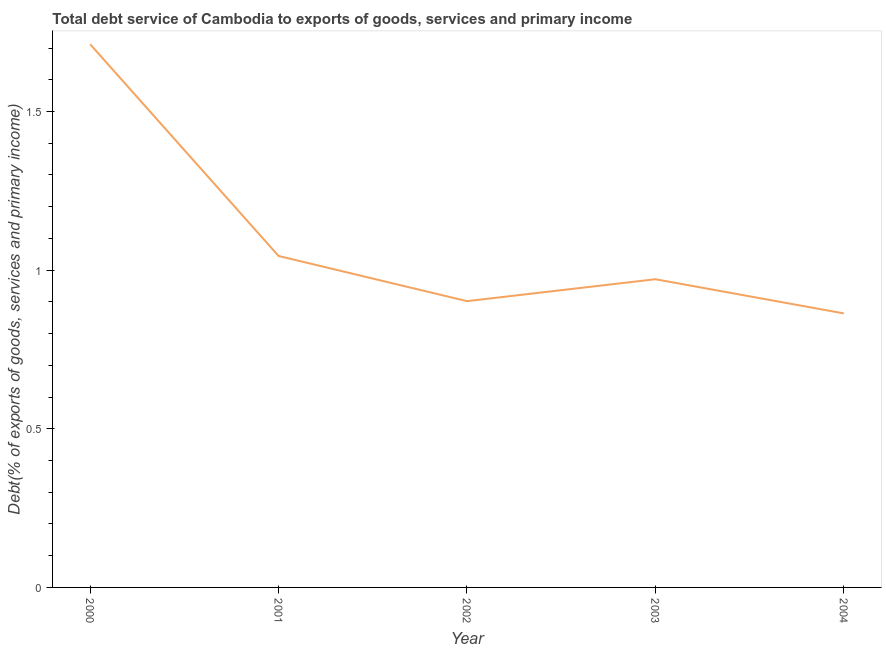What is the total debt service in 2001?
Offer a terse response. 1.04. Across all years, what is the maximum total debt service?
Offer a terse response. 1.71. Across all years, what is the minimum total debt service?
Ensure brevity in your answer.  0.86. In which year was the total debt service maximum?
Make the answer very short. 2000. What is the sum of the total debt service?
Make the answer very short. 5.49. What is the difference between the total debt service in 2002 and 2004?
Offer a very short reply. 0.04. What is the average total debt service per year?
Your answer should be very brief. 1.1. What is the median total debt service?
Provide a succinct answer. 0.97. In how many years, is the total debt service greater than 1.6 %?
Make the answer very short. 1. Do a majority of the years between 2001 and 2003 (inclusive) have total debt service greater than 1.5 %?
Give a very brief answer. No. What is the ratio of the total debt service in 2003 to that in 2004?
Your response must be concise. 1.12. Is the total debt service in 2000 less than that in 2002?
Give a very brief answer. No. Is the difference between the total debt service in 2002 and 2004 greater than the difference between any two years?
Keep it short and to the point. No. What is the difference between the highest and the second highest total debt service?
Ensure brevity in your answer.  0.67. What is the difference between the highest and the lowest total debt service?
Give a very brief answer. 0.85. In how many years, is the total debt service greater than the average total debt service taken over all years?
Ensure brevity in your answer.  1. What is the difference between two consecutive major ticks on the Y-axis?
Offer a very short reply. 0.5. Are the values on the major ticks of Y-axis written in scientific E-notation?
Your response must be concise. No. Does the graph contain any zero values?
Keep it short and to the point. No. What is the title of the graph?
Your response must be concise. Total debt service of Cambodia to exports of goods, services and primary income. What is the label or title of the Y-axis?
Offer a very short reply. Debt(% of exports of goods, services and primary income). What is the Debt(% of exports of goods, services and primary income) of 2000?
Keep it short and to the point. 1.71. What is the Debt(% of exports of goods, services and primary income) of 2001?
Your answer should be very brief. 1.04. What is the Debt(% of exports of goods, services and primary income) in 2002?
Your answer should be very brief. 0.9. What is the Debt(% of exports of goods, services and primary income) in 2003?
Make the answer very short. 0.97. What is the Debt(% of exports of goods, services and primary income) of 2004?
Your answer should be very brief. 0.86. What is the difference between the Debt(% of exports of goods, services and primary income) in 2000 and 2001?
Provide a short and direct response. 0.67. What is the difference between the Debt(% of exports of goods, services and primary income) in 2000 and 2002?
Give a very brief answer. 0.81. What is the difference between the Debt(% of exports of goods, services and primary income) in 2000 and 2003?
Provide a succinct answer. 0.74. What is the difference between the Debt(% of exports of goods, services and primary income) in 2000 and 2004?
Offer a terse response. 0.85. What is the difference between the Debt(% of exports of goods, services and primary income) in 2001 and 2002?
Provide a short and direct response. 0.14. What is the difference between the Debt(% of exports of goods, services and primary income) in 2001 and 2003?
Give a very brief answer. 0.07. What is the difference between the Debt(% of exports of goods, services and primary income) in 2001 and 2004?
Give a very brief answer. 0.18. What is the difference between the Debt(% of exports of goods, services and primary income) in 2002 and 2003?
Ensure brevity in your answer.  -0.07. What is the difference between the Debt(% of exports of goods, services and primary income) in 2002 and 2004?
Your answer should be very brief. 0.04. What is the difference between the Debt(% of exports of goods, services and primary income) in 2003 and 2004?
Provide a succinct answer. 0.11. What is the ratio of the Debt(% of exports of goods, services and primary income) in 2000 to that in 2001?
Keep it short and to the point. 1.64. What is the ratio of the Debt(% of exports of goods, services and primary income) in 2000 to that in 2002?
Provide a succinct answer. 1.9. What is the ratio of the Debt(% of exports of goods, services and primary income) in 2000 to that in 2003?
Provide a succinct answer. 1.76. What is the ratio of the Debt(% of exports of goods, services and primary income) in 2000 to that in 2004?
Your answer should be very brief. 1.98. What is the ratio of the Debt(% of exports of goods, services and primary income) in 2001 to that in 2002?
Offer a terse response. 1.16. What is the ratio of the Debt(% of exports of goods, services and primary income) in 2001 to that in 2003?
Provide a short and direct response. 1.07. What is the ratio of the Debt(% of exports of goods, services and primary income) in 2001 to that in 2004?
Provide a short and direct response. 1.21. What is the ratio of the Debt(% of exports of goods, services and primary income) in 2002 to that in 2003?
Offer a terse response. 0.93. What is the ratio of the Debt(% of exports of goods, services and primary income) in 2002 to that in 2004?
Your answer should be very brief. 1.04. What is the ratio of the Debt(% of exports of goods, services and primary income) in 2003 to that in 2004?
Offer a very short reply. 1.12. 